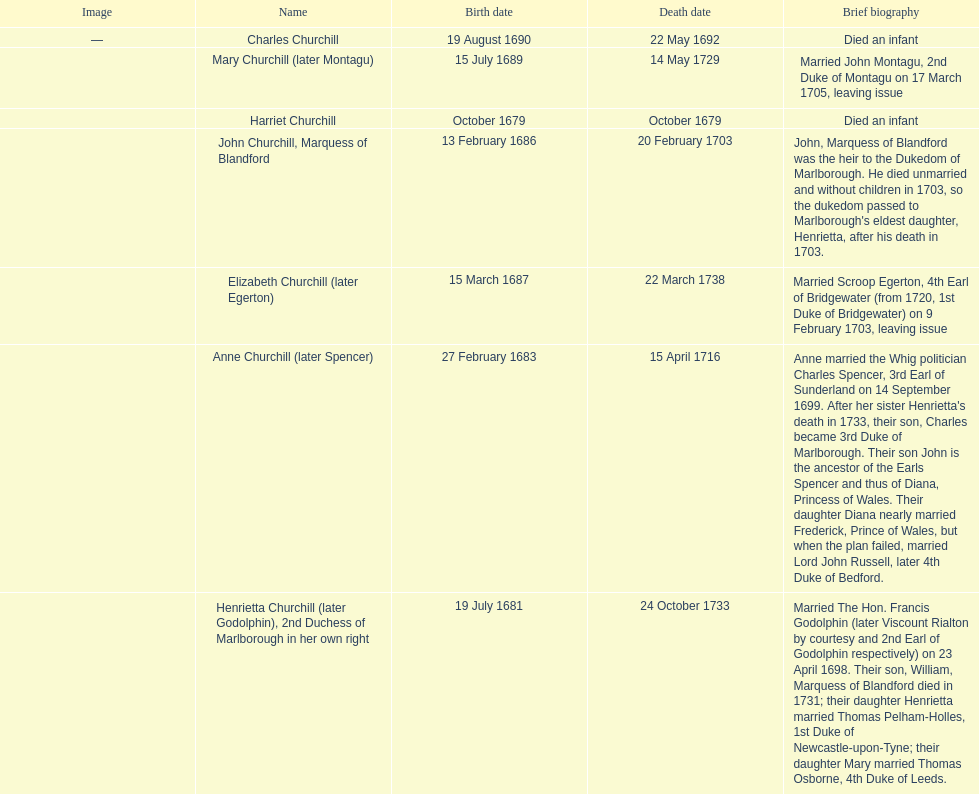What is the total number of children listed? 7. 